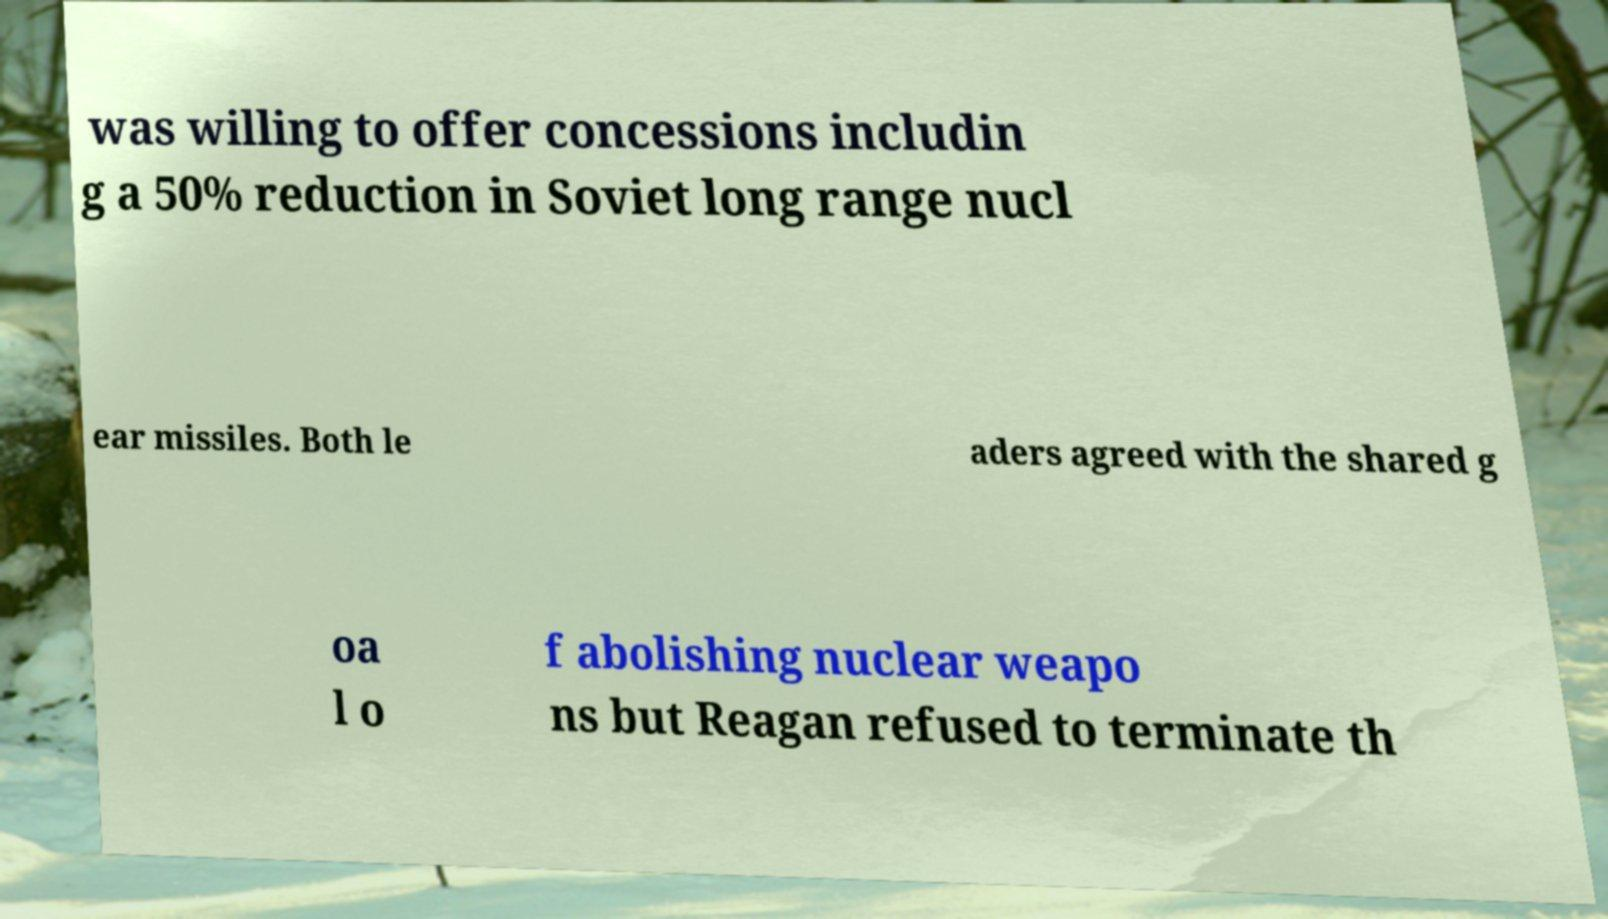I need the written content from this picture converted into text. Can you do that? was willing to offer concessions includin g a 50% reduction in Soviet long range nucl ear missiles. Both le aders agreed with the shared g oa l o f abolishing nuclear weapo ns but Reagan refused to terminate th 